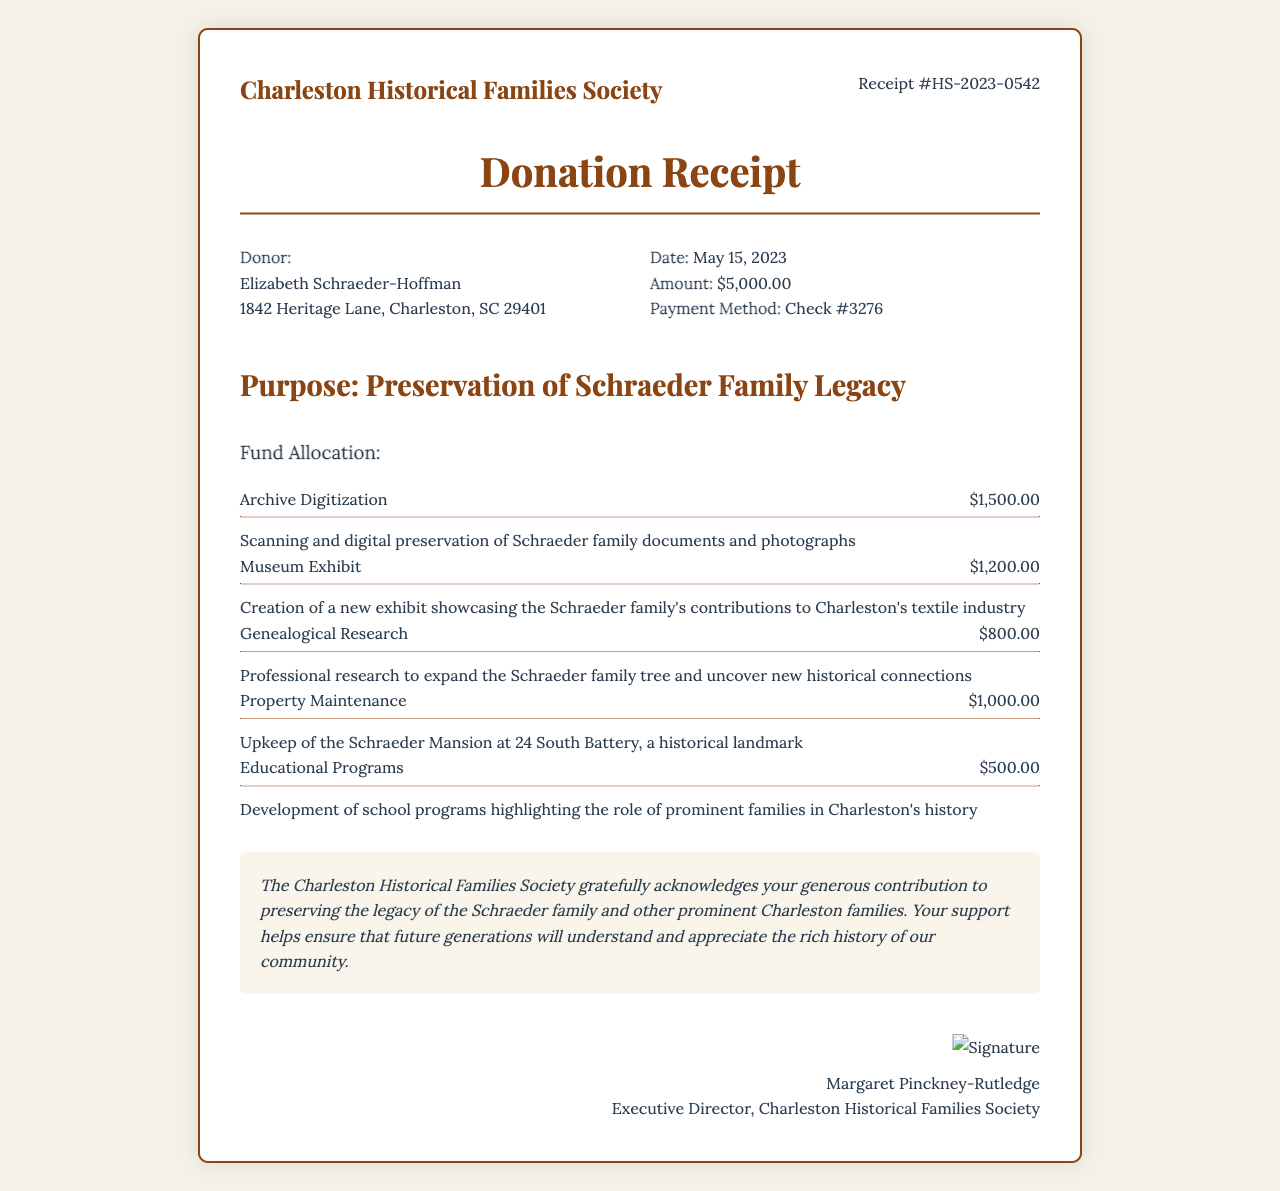What is the receipt number? The receipt number is a unique identifier assigned to this document, which is HS-2023-0542.
Answer: HS-2023-0542 Who is the donor? The donor is the individual or organization making the contribution, which in this case is Elizabeth Schraeder-Hoffman.
Answer: Elizabeth Schraeder-Hoffman How much was donated? The donation amount is stated as the total contribution made by the donor, which is $5,000.00.
Answer: $5,000.00 What organization is receiving the donation? The organization is the entity that will benefit from the donation, which is the Charleston Historical Families Society.
Answer: Charleston Historical Families Society What is the purpose of the donation? The purpose outlines the specific reason for the donation, which is for the preservation of the Schraeder family legacy.
Answer: Preservation of Schraeder Family Legacy What percentage of the donation is allocated for Archive Digitization? This involves calculating the specific allocation for that category from the total donation amount. Archive Digitization receives $1,500.00 out of $5,000.00.
Answer: 30% How much is allocated for Educational Programs? This refers to the amount set aside in the budget for funding educational initiatives mentioned in the document. The amount for Educational Programs is $500.00.
Answer: $500.00 What is the tax-deductible amount? This refers to the portion of the donation that can be claimed for tax purposes, which is equal to the donation amount.
Answer: $5,000.00 Who signed the receipt? The individual who authorized the receipt typically includes their name and title, in this case, the signature is from Margaret Pinckney-Rutledge.
Answer: Margaret Pinckney-Rutledge 